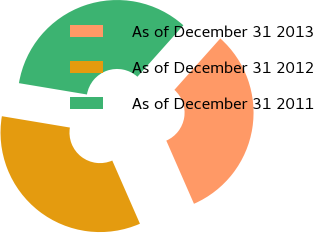<chart> <loc_0><loc_0><loc_500><loc_500><pie_chart><fcel>As of December 31 2013<fcel>As of December 31 2012<fcel>As of December 31 2011<nl><fcel>31.83%<fcel>34.2%<fcel>33.97%<nl></chart> 